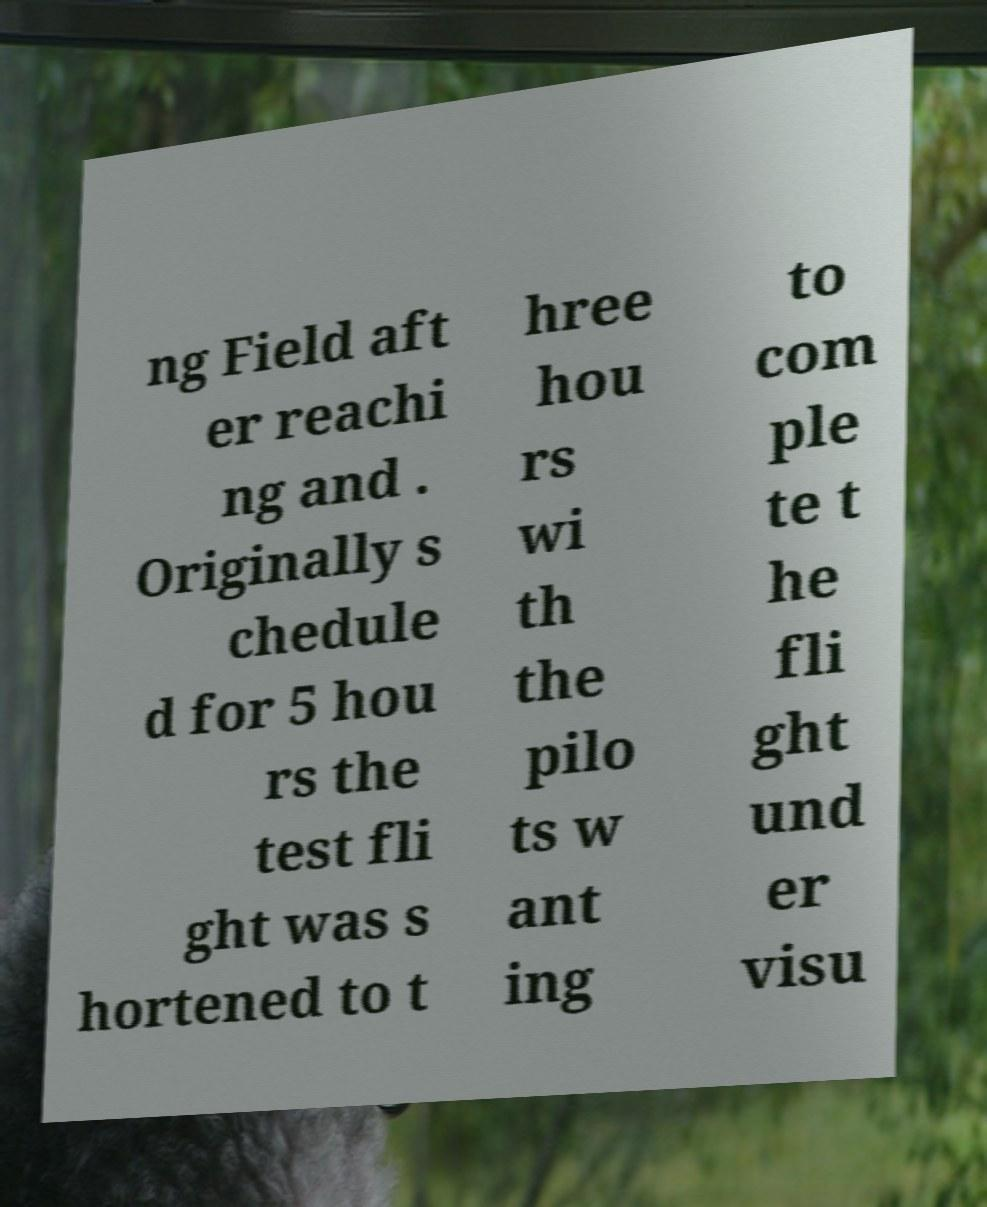Can you read and provide the text displayed in the image?This photo seems to have some interesting text. Can you extract and type it out for me? ng Field aft er reachi ng and . Originally s chedule d for 5 hou rs the test fli ght was s hortened to t hree hou rs wi th the pilo ts w ant ing to com ple te t he fli ght und er visu 